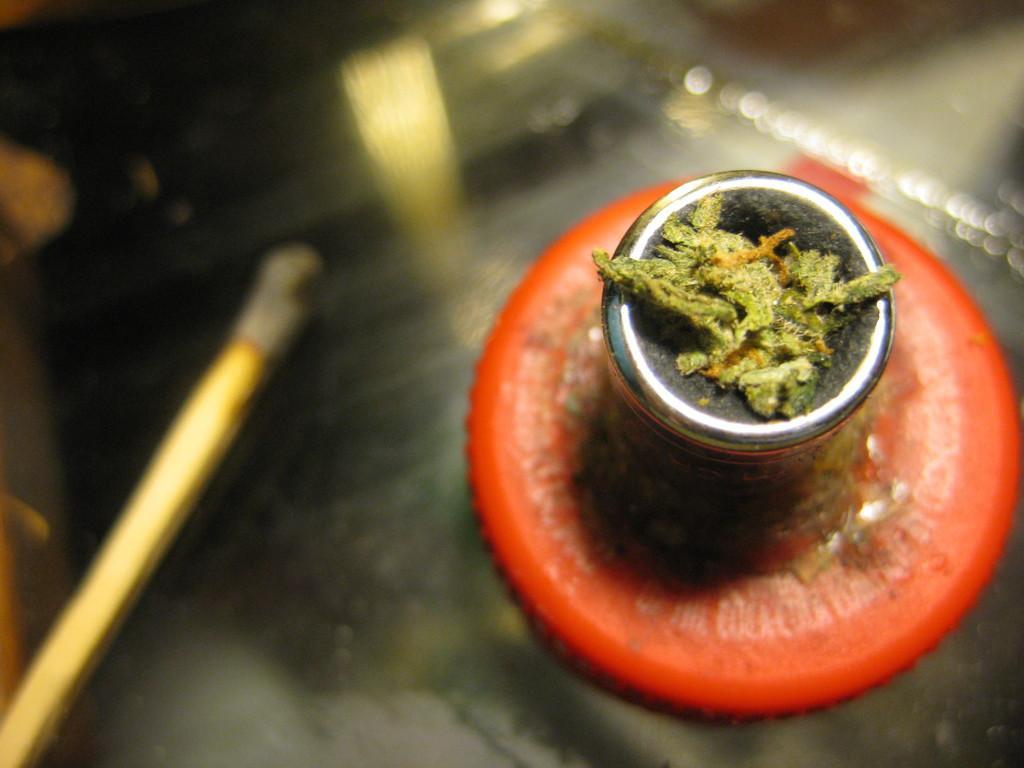Please provide a concise description of this image. As we can see in the image there is a table and a glass on plate. 